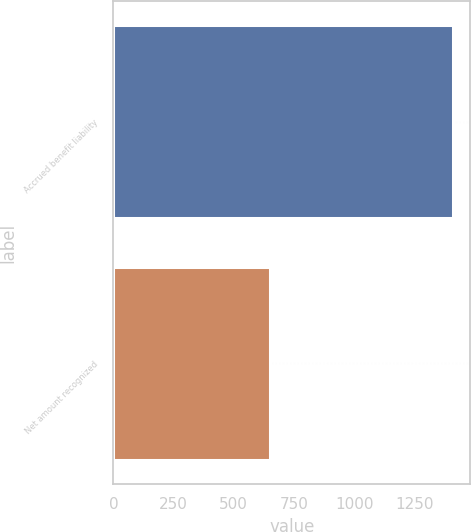Convert chart. <chart><loc_0><loc_0><loc_500><loc_500><bar_chart><fcel>Accrued benefit liability<fcel>Net amount recognized<nl><fcel>1412<fcel>650<nl></chart> 